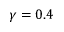<formula> <loc_0><loc_0><loc_500><loc_500>\gamma = 0 . 4</formula> 